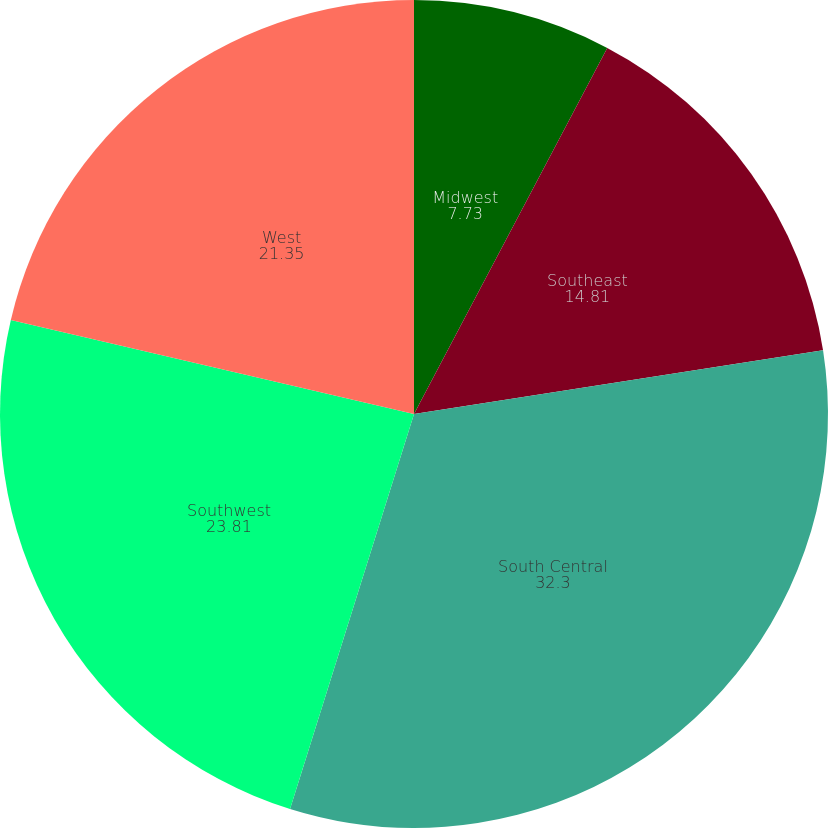Convert chart to OTSL. <chart><loc_0><loc_0><loc_500><loc_500><pie_chart><fcel>Midwest<fcel>Southeast<fcel>South Central<fcel>Southwest<fcel>West<nl><fcel>7.73%<fcel>14.81%<fcel>32.3%<fcel>23.81%<fcel>21.35%<nl></chart> 